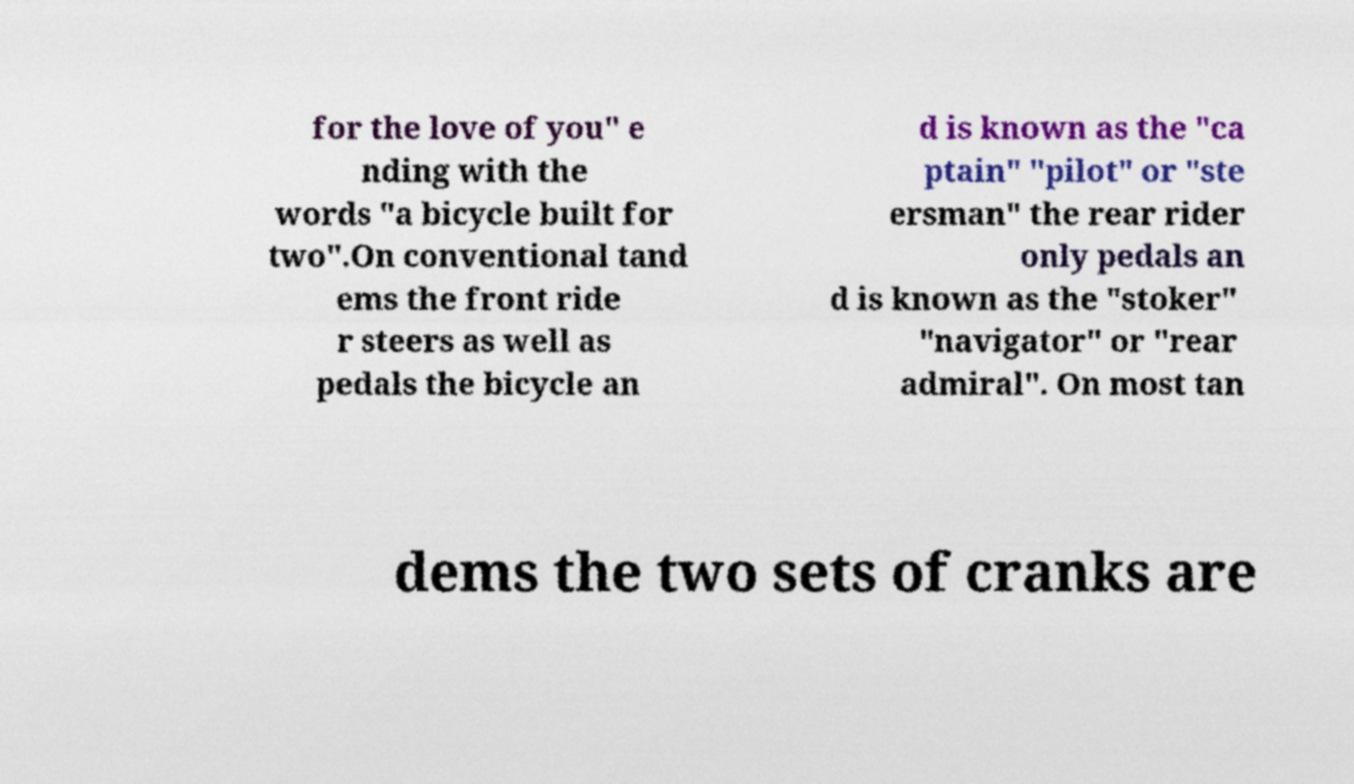What messages or text are displayed in this image? I need them in a readable, typed format. for the love of you" e nding with the words "a bicycle built for two".On conventional tand ems the front ride r steers as well as pedals the bicycle an d is known as the "ca ptain" "pilot" or "ste ersman" the rear rider only pedals an d is known as the "stoker" "navigator" or "rear admiral". On most tan dems the two sets of cranks are 